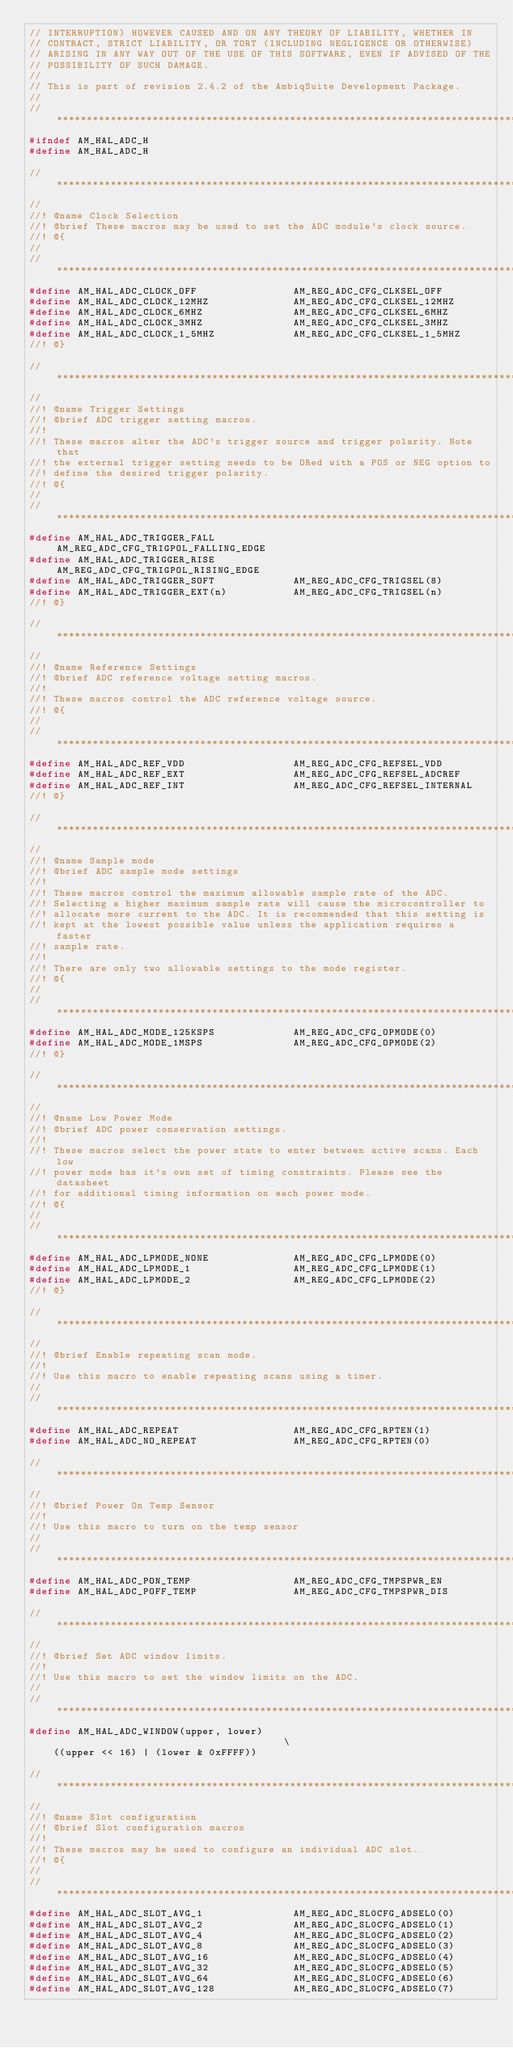Convert code to text. <code><loc_0><loc_0><loc_500><loc_500><_C_>// INTERRUPTION) HOWEVER CAUSED AND ON ANY THEORY OF LIABILITY, WHETHER IN
// CONTRACT, STRICT LIABILITY, OR TORT (INCLUDING NEGLIGENCE OR OTHERWISE)
// ARISING IN ANY WAY OUT OF THE USE OF THIS SOFTWARE, EVEN IF ADVISED OF THE
// POSSIBILITY OF SUCH DAMAGE.
//
// This is part of revision 2.4.2 of the AmbiqSuite Development Package.
//
//*****************************************************************************
#ifndef AM_HAL_ADC_H
#define AM_HAL_ADC_H

//*****************************************************************************
//
//! @name Clock Selection
//! @brief These macros may be used to set the ADC module's clock source.
//! @{
//
//*****************************************************************************
#define AM_HAL_ADC_CLOCK_OFF                AM_REG_ADC_CFG_CLKSEL_OFF
#define AM_HAL_ADC_CLOCK_12MHZ              AM_REG_ADC_CFG_CLKSEL_12MHZ
#define AM_HAL_ADC_CLOCK_6MHZ               AM_REG_ADC_CFG_CLKSEL_6MHZ
#define AM_HAL_ADC_CLOCK_3MHZ               AM_REG_ADC_CFG_CLKSEL_3MHZ
#define AM_HAL_ADC_CLOCK_1_5MHZ             AM_REG_ADC_CFG_CLKSEL_1_5MHZ
//! @}

//*****************************************************************************
//
//! @name Trigger Settings
//! @brief ADC trigger setting macros.
//!
//! These macros alter the ADC's trigger source and trigger polarity. Note that
//! the external trigger setting needs to be ORed with a POS or NEG option to
//! define the desired trigger polarity.
//! @{
//
//*****************************************************************************
#define AM_HAL_ADC_TRIGGER_FALL             AM_REG_ADC_CFG_TRIGPOL_FALLING_EDGE
#define AM_HAL_ADC_TRIGGER_RISE             AM_REG_ADC_CFG_TRIGPOL_RISING_EDGE
#define AM_HAL_ADC_TRIGGER_SOFT             AM_REG_ADC_CFG_TRIGSEL(8)
#define AM_HAL_ADC_TRIGGER_EXT(n)           AM_REG_ADC_CFG_TRIGSEL(n)
//! @}

//*****************************************************************************
//
//! @name Reference Settings
//! @brief ADC reference voltage setting macros.
//!
//! These macros control the ADC reference voltage source.
//! @{
//
//*****************************************************************************
#define AM_HAL_ADC_REF_VDD                  AM_REG_ADC_CFG_REFSEL_VDD
#define AM_HAL_ADC_REF_EXT                  AM_REG_ADC_CFG_REFSEL_ADCREF
#define AM_HAL_ADC_REF_INT                  AM_REG_ADC_CFG_REFSEL_INTERNAL
//! @}

//*****************************************************************************
//
//! @name Sample mode
//! @brief ADC sample mode settings
//!
//! These macros control the maximum allowable sample rate of the ADC.
//! Selecting a higher maximum sample rate will cause the microcontroller to
//! allocate more current to the ADC. It is recommended that this setting is
//! kept at the lowest possible value unless the application requires a faster
//! sample rate.
//!
//! There are only two allowable settings to the mode register.
//! @{
//
//*****************************************************************************
#define AM_HAL_ADC_MODE_125KSPS             AM_REG_ADC_CFG_OPMODE(0)
#define AM_HAL_ADC_MODE_1MSPS               AM_REG_ADC_CFG_OPMODE(2)
//! @}

//*****************************************************************************
//
//! @name Low Power Mode
//! @brief ADC power conservation settings.
//!
//! These macros select the power state to enter between active scans. Each low
//! power mode has it's own set of timing constraints. Please see the datasheet
//! for additional timing information on each power mode.
//! @{
//
//*****************************************************************************
#define AM_HAL_ADC_LPMODE_NONE              AM_REG_ADC_CFG_LPMODE(0)
#define AM_HAL_ADC_LPMODE_1                 AM_REG_ADC_CFG_LPMODE(1)
#define AM_HAL_ADC_LPMODE_2                 AM_REG_ADC_CFG_LPMODE(2)
//! @}

//*****************************************************************************
//
//! @brief Enable repeating scan mode.
//!
//! Use this macro to enable repeating scans using a timer.
//
//*****************************************************************************
#define AM_HAL_ADC_REPEAT                   AM_REG_ADC_CFG_RPTEN(1)
#define AM_HAL_ADC_NO_REPEAT                AM_REG_ADC_CFG_RPTEN(0)

//*****************************************************************************
//
//! @brief Power On Temp Sensor
//!
//! Use this macro to turn on the temp sensor
//
//*****************************************************************************
#define AM_HAL_ADC_PON_TEMP                 AM_REG_ADC_CFG_TMPSPWR_EN
#define AM_HAL_ADC_POFF_TEMP                AM_REG_ADC_CFG_TMPSPWR_DIS

//*****************************************************************************
//
//! @brief Set ADC window limits.
//!
//! Use this macro to set the window limits on the ADC.
//
//*****************************************************************************
#define AM_HAL_ADC_WINDOW(upper, lower)                                       \
    ((upper << 16) | (lower & 0xFFFF))

//*****************************************************************************
//
//! @name Slot configuration
//! @brief Slot configuration macros
//!
//! These macros may be used to configure an individual ADC slot.
//! @{
//
//*****************************************************************************
#define AM_HAL_ADC_SLOT_AVG_1               AM_REG_ADC_SL0CFG_ADSEL0(0)
#define AM_HAL_ADC_SLOT_AVG_2               AM_REG_ADC_SL0CFG_ADSEL0(1)
#define AM_HAL_ADC_SLOT_AVG_4               AM_REG_ADC_SL0CFG_ADSEL0(2)
#define AM_HAL_ADC_SLOT_AVG_8               AM_REG_ADC_SL0CFG_ADSEL0(3)
#define AM_HAL_ADC_SLOT_AVG_16              AM_REG_ADC_SL0CFG_ADSEL0(4)
#define AM_HAL_ADC_SLOT_AVG_32              AM_REG_ADC_SL0CFG_ADSEL0(5)
#define AM_HAL_ADC_SLOT_AVG_64              AM_REG_ADC_SL0CFG_ADSEL0(6)
#define AM_HAL_ADC_SLOT_AVG_128             AM_REG_ADC_SL0CFG_ADSEL0(7)
</code> 